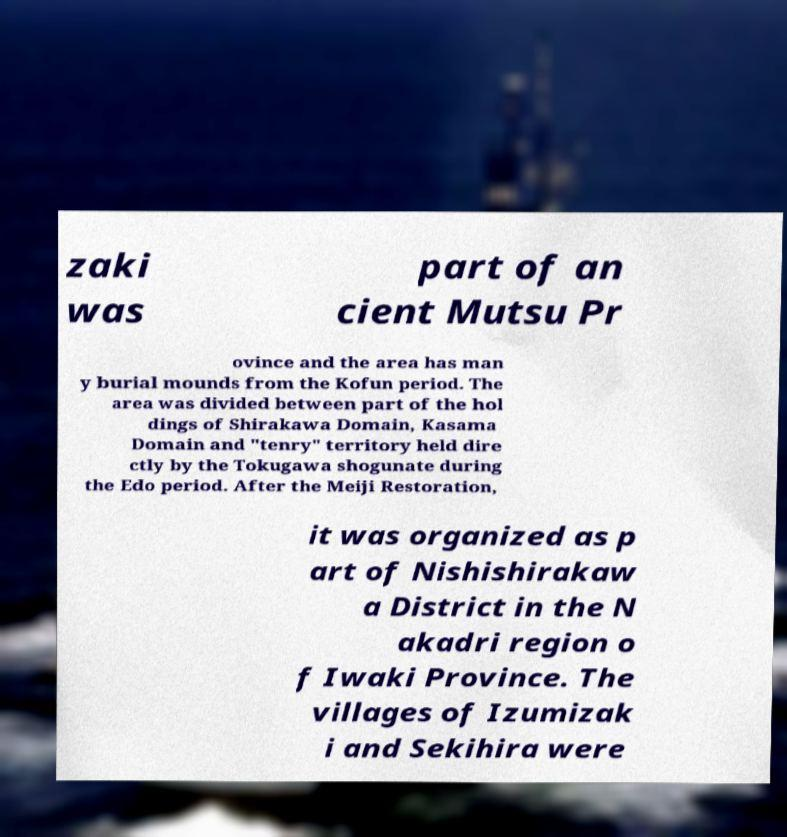For documentation purposes, I need the text within this image transcribed. Could you provide that? zaki was part of an cient Mutsu Pr ovince and the area has man y burial mounds from the Kofun period. The area was divided between part of the hol dings of Shirakawa Domain, Kasama Domain and "tenry" territory held dire ctly by the Tokugawa shogunate during the Edo period. After the Meiji Restoration, it was organized as p art of Nishishirakaw a District in the N akadri region o f Iwaki Province. The villages of Izumizak i and Sekihira were 